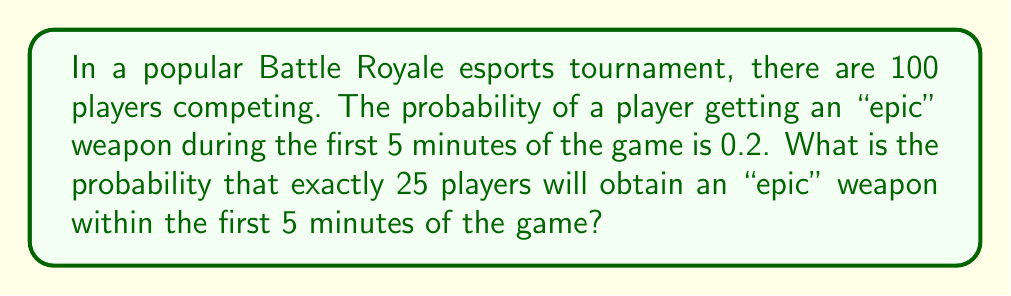Solve this math problem. Let's approach this step-by-step using the binomial probability distribution:

1) This scenario follows a binomial distribution because:
   - There are a fixed number of trials (100 players)
   - Each trial has two possible outcomes (getting an epic weapon or not)
   - The probability of success (getting an epic weapon) is constant for each trial
   - The trials are independent

2) The binomial probability formula is:

   $$P(X = k) = \binom{n}{k} p^k (1-p)^{n-k}$$

   Where:
   $n$ = number of trials (100 players)
   $k$ = number of successes (25 players getting epic weapons)
   $p$ = probability of success on each trial (0.2)

3) Let's substitute our values:

   $$P(X = 25) = \binom{100}{25} (0.2)^{25} (1-0.2)^{100-25}$$

4) Simplify:

   $$P(X = 25) = \binom{100}{25} (0.2)^{25} (0.8)^{75}$$

5) Calculate the binomial coefficient:

   $$\binom{100}{25} = \frac{100!}{25!(100-25)!} = \frac{100!}{25!75!} \approx 2.4251 \times 10^{23}$$

6) Now, let's calculate the full probability:

   $$P(X = 25) \approx (2.4251 \times 10^{23}) \times (0.2^{25}) \times (0.8^{75})$$

7) Using a calculator or computer (due to the large numbers involved):

   $$P(X = 25) \approx 0.0872 \text{ or } 8.72\%$$
Answer: 0.0872 